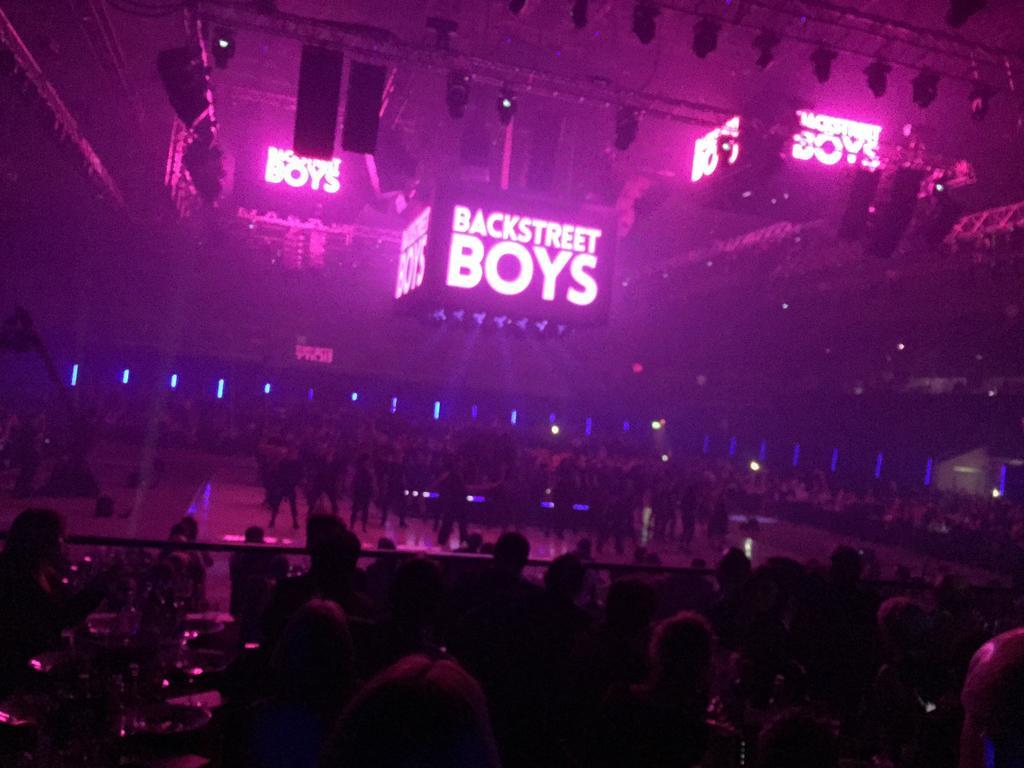Describe this image in one or two sentences. As we can see in the image there are few people here and there, wall, lights and stage. 